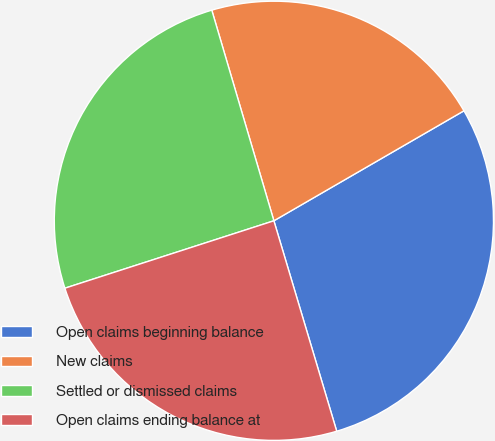Convert chart. <chart><loc_0><loc_0><loc_500><loc_500><pie_chart><fcel>Open claims beginning balance<fcel>New claims<fcel>Settled or dismissed claims<fcel>Open claims ending balance at<nl><fcel>28.73%<fcel>21.21%<fcel>25.4%<fcel>24.65%<nl></chart> 